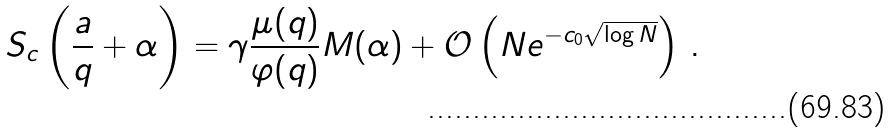Convert formula to latex. <formula><loc_0><loc_0><loc_500><loc_500>S _ { c } \left ( \frac { a } { q } + \alpha \right ) = \gamma \frac { \mu ( q ) } { \varphi ( q ) } M ( \alpha ) + \mathcal { O } \left ( N e ^ { - c _ { 0 } \sqrt { \log N } } \right ) \, .</formula> 